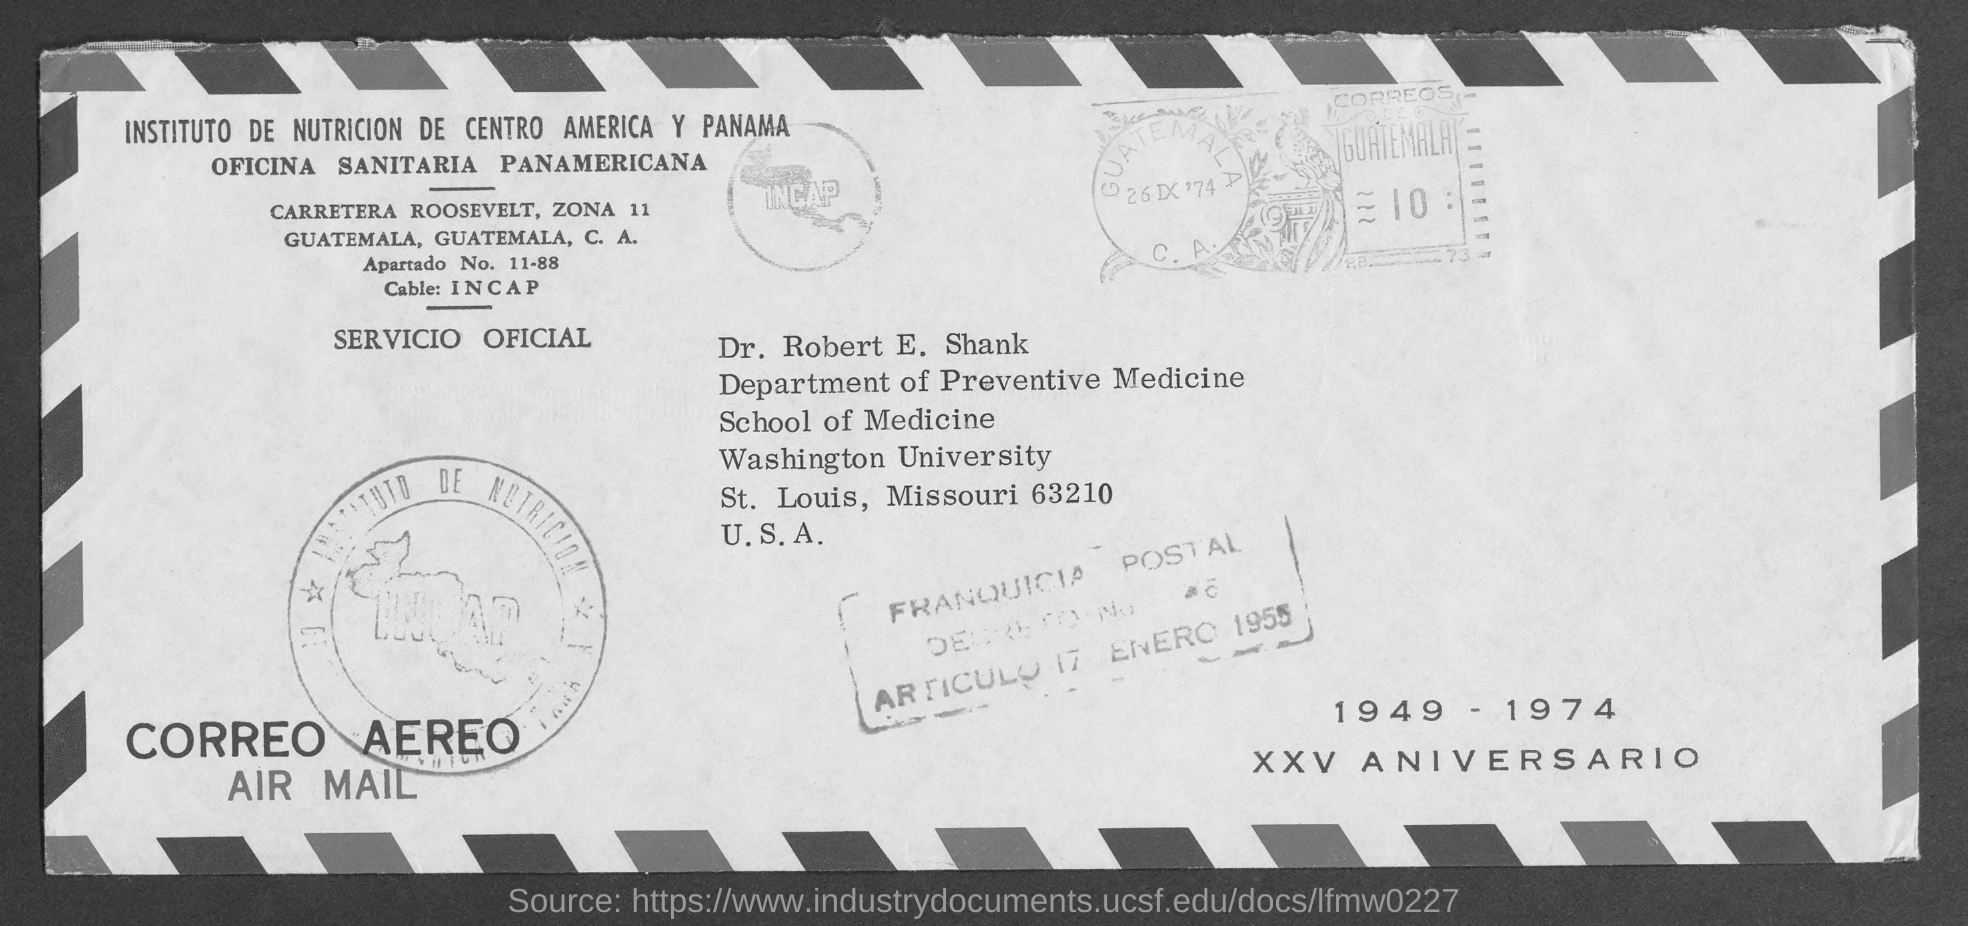To Whom is this mail addressed to?
Your answer should be compact. Dr. Robert E. Shank. Who is this mail from?
Offer a terse response. CARRETERA ROOSEVELT. 